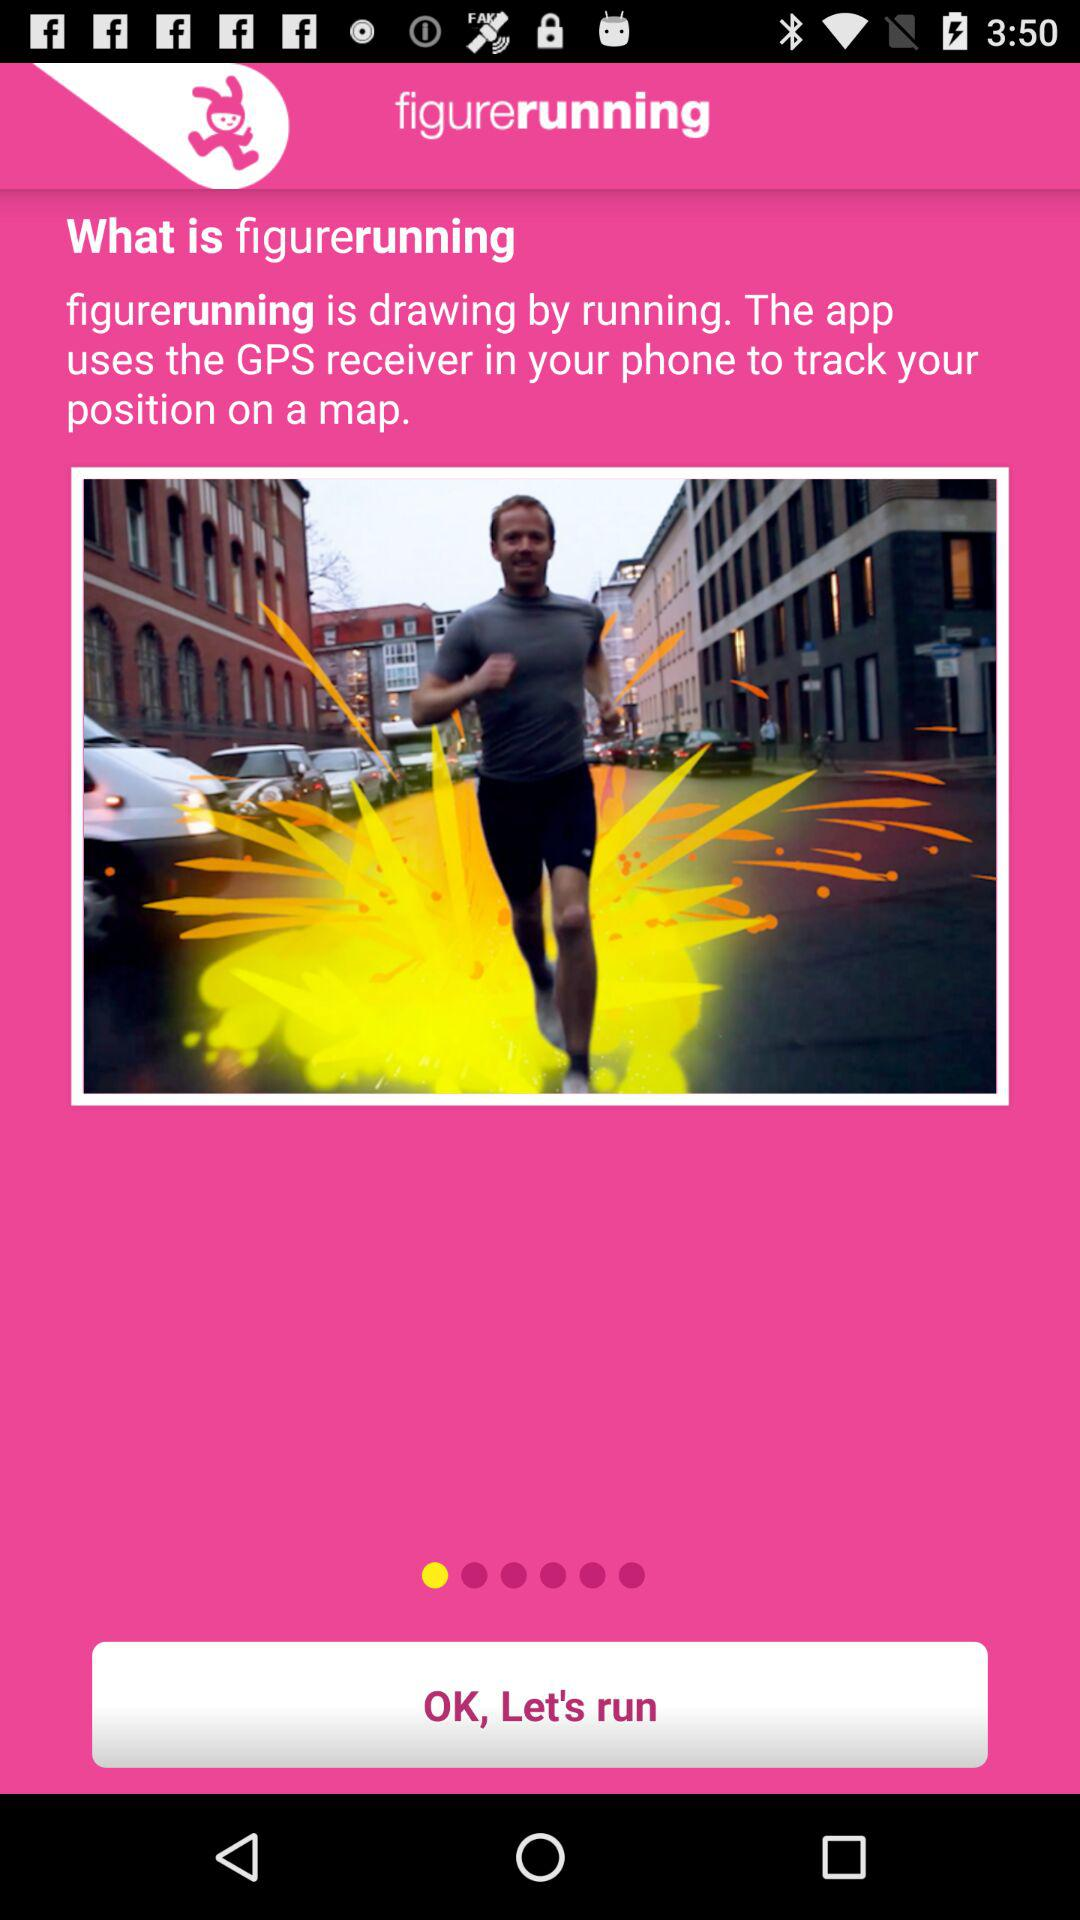How does "figurerunning" work? It uses the GPS receiver in your phone to track your position on a map. 